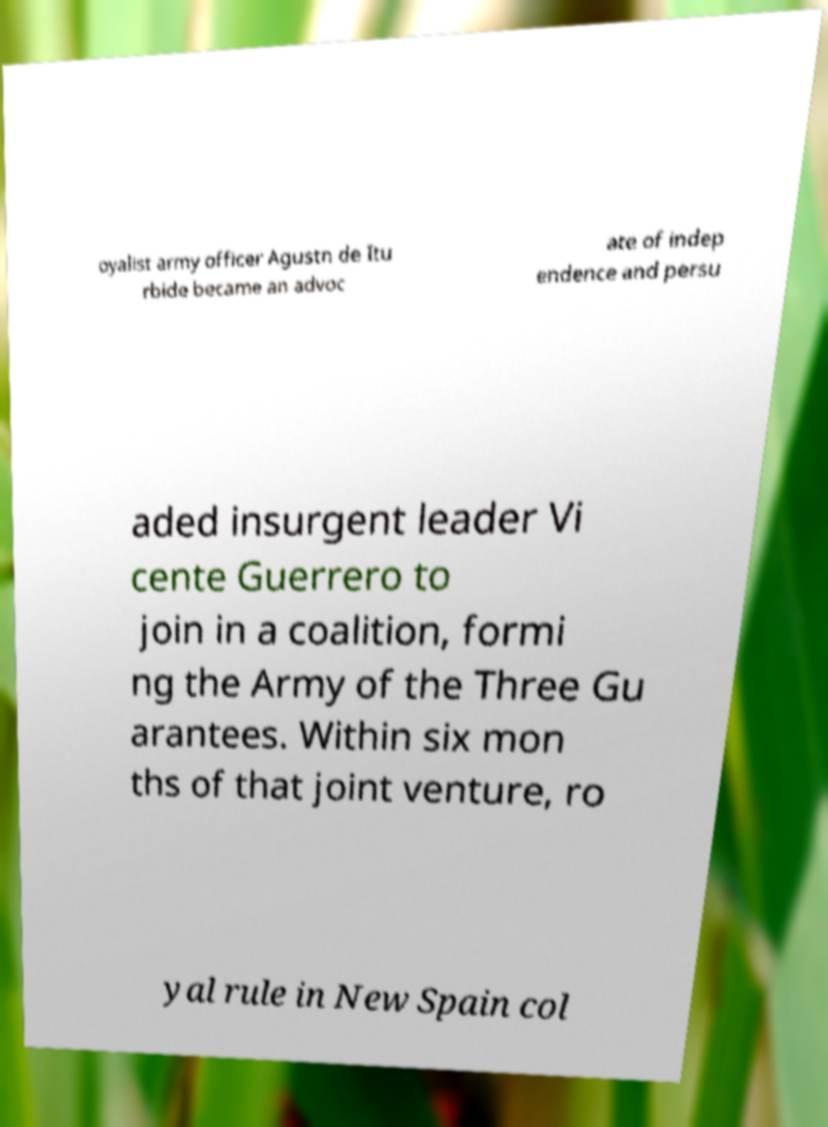I need the written content from this picture converted into text. Can you do that? oyalist army officer Agustn de Itu rbide became an advoc ate of indep endence and persu aded insurgent leader Vi cente Guerrero to join in a coalition, formi ng the Army of the Three Gu arantees. Within six mon ths of that joint venture, ro yal rule in New Spain col 